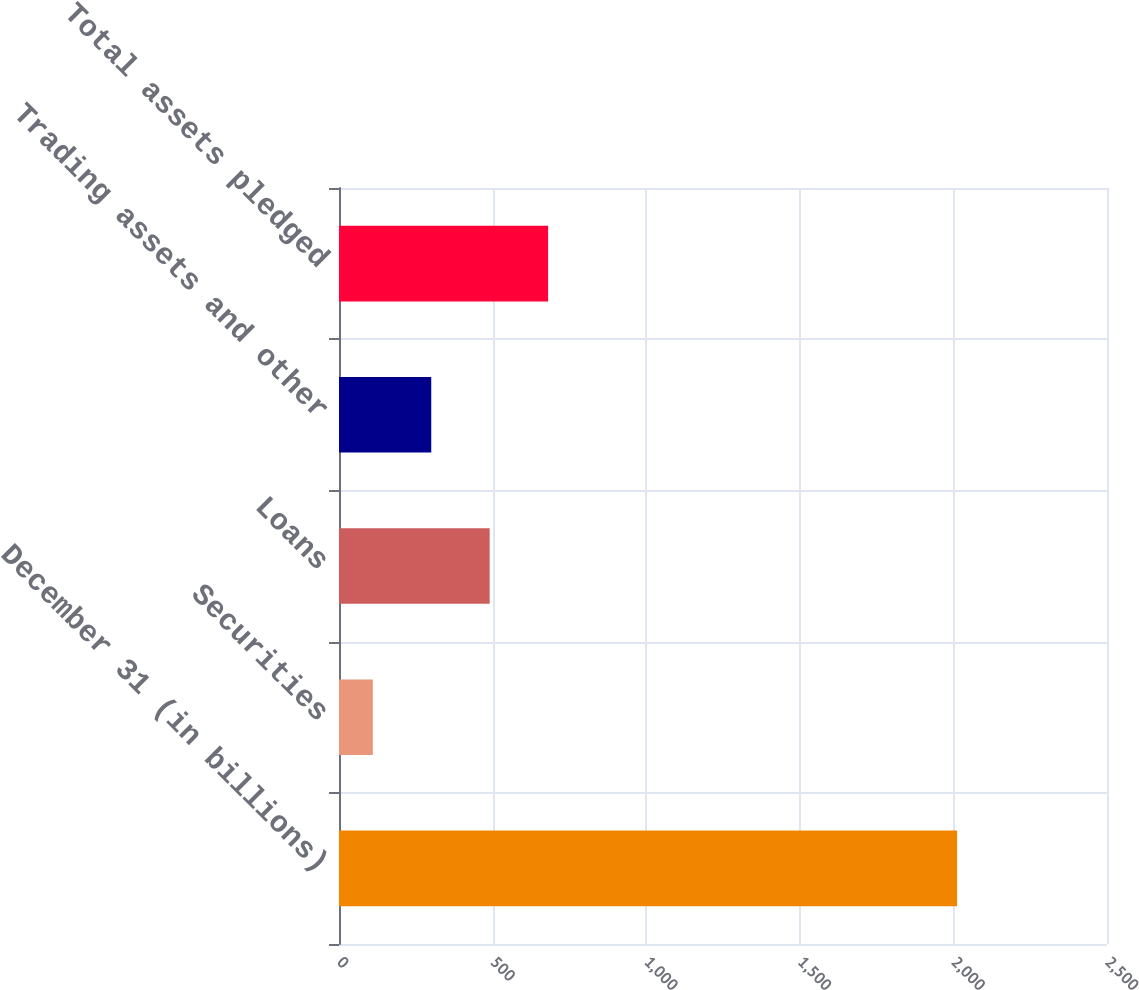Convert chart to OTSL. <chart><loc_0><loc_0><loc_500><loc_500><bar_chart><fcel>December 31 (in billions)<fcel>Securities<fcel>Loans<fcel>Trading assets and other<fcel>Total assets pledged<nl><fcel>2012<fcel>110.1<fcel>490.48<fcel>300.29<fcel>680.67<nl></chart> 